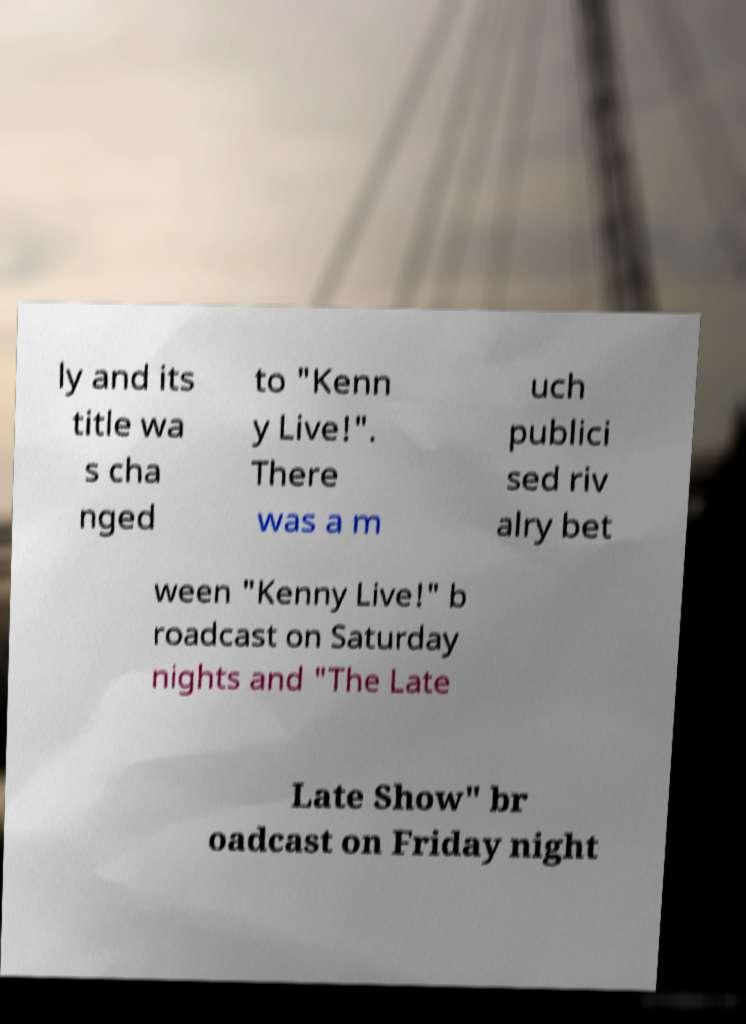Could you extract and type out the text from this image? ly and its title wa s cha nged to "Kenn y Live!". There was a m uch publici sed riv alry bet ween "Kenny Live!" b roadcast on Saturday nights and "The Late Late Show" br oadcast on Friday night 